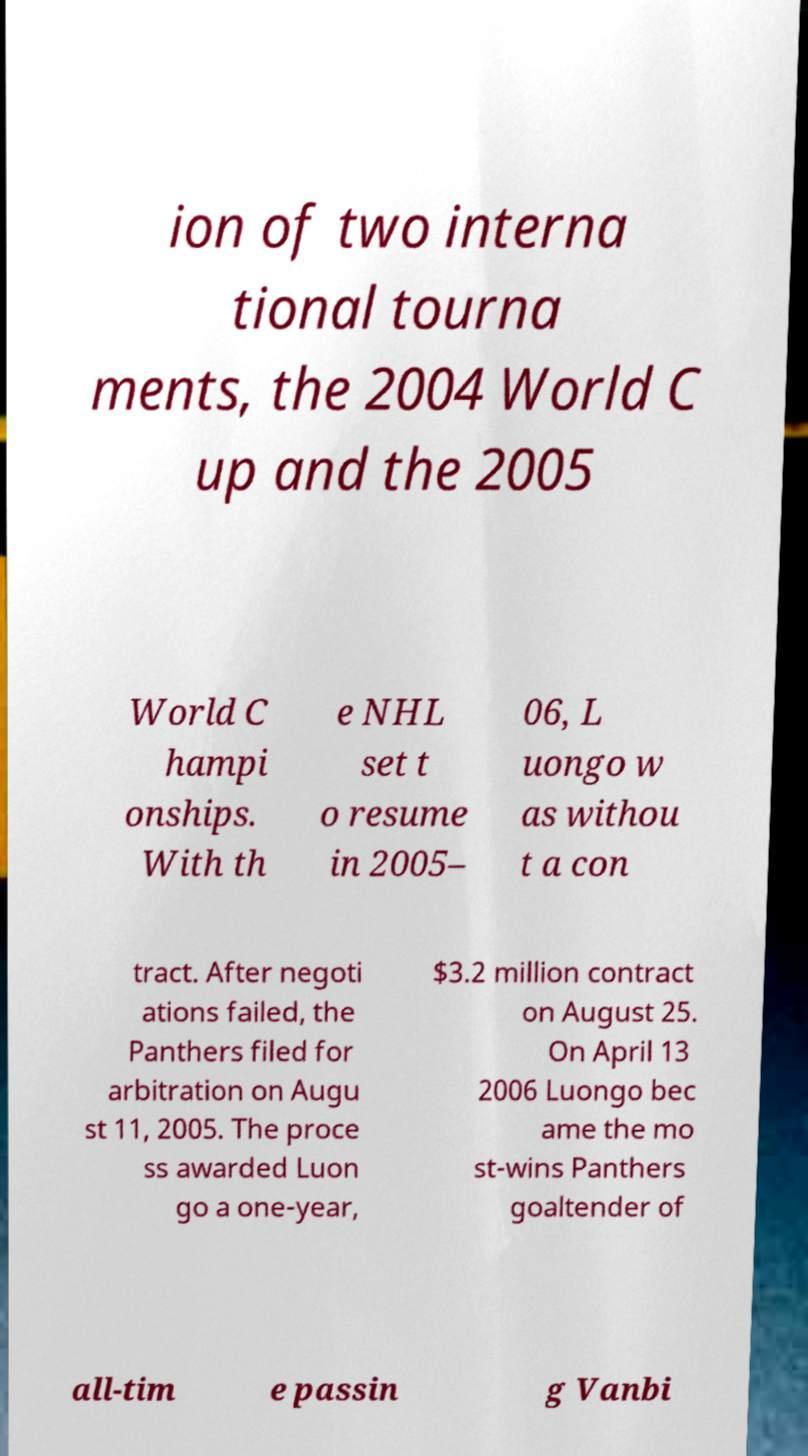I need the written content from this picture converted into text. Can you do that? ion of two interna tional tourna ments, the 2004 World C up and the 2005 World C hampi onships. With th e NHL set t o resume in 2005– 06, L uongo w as withou t a con tract. After negoti ations failed, the Panthers filed for arbitration on Augu st 11, 2005. The proce ss awarded Luon go a one-year, $3.2 million contract on August 25. On April 13 2006 Luongo bec ame the mo st-wins Panthers goaltender of all-tim e passin g Vanbi 